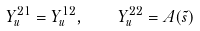Convert formula to latex. <formula><loc_0><loc_0><loc_500><loc_500>Y _ { u } ^ { 2 1 } = Y _ { u } ^ { 1 2 } , \quad Y _ { u } ^ { 2 2 } = A ( \tilde { s } )</formula> 